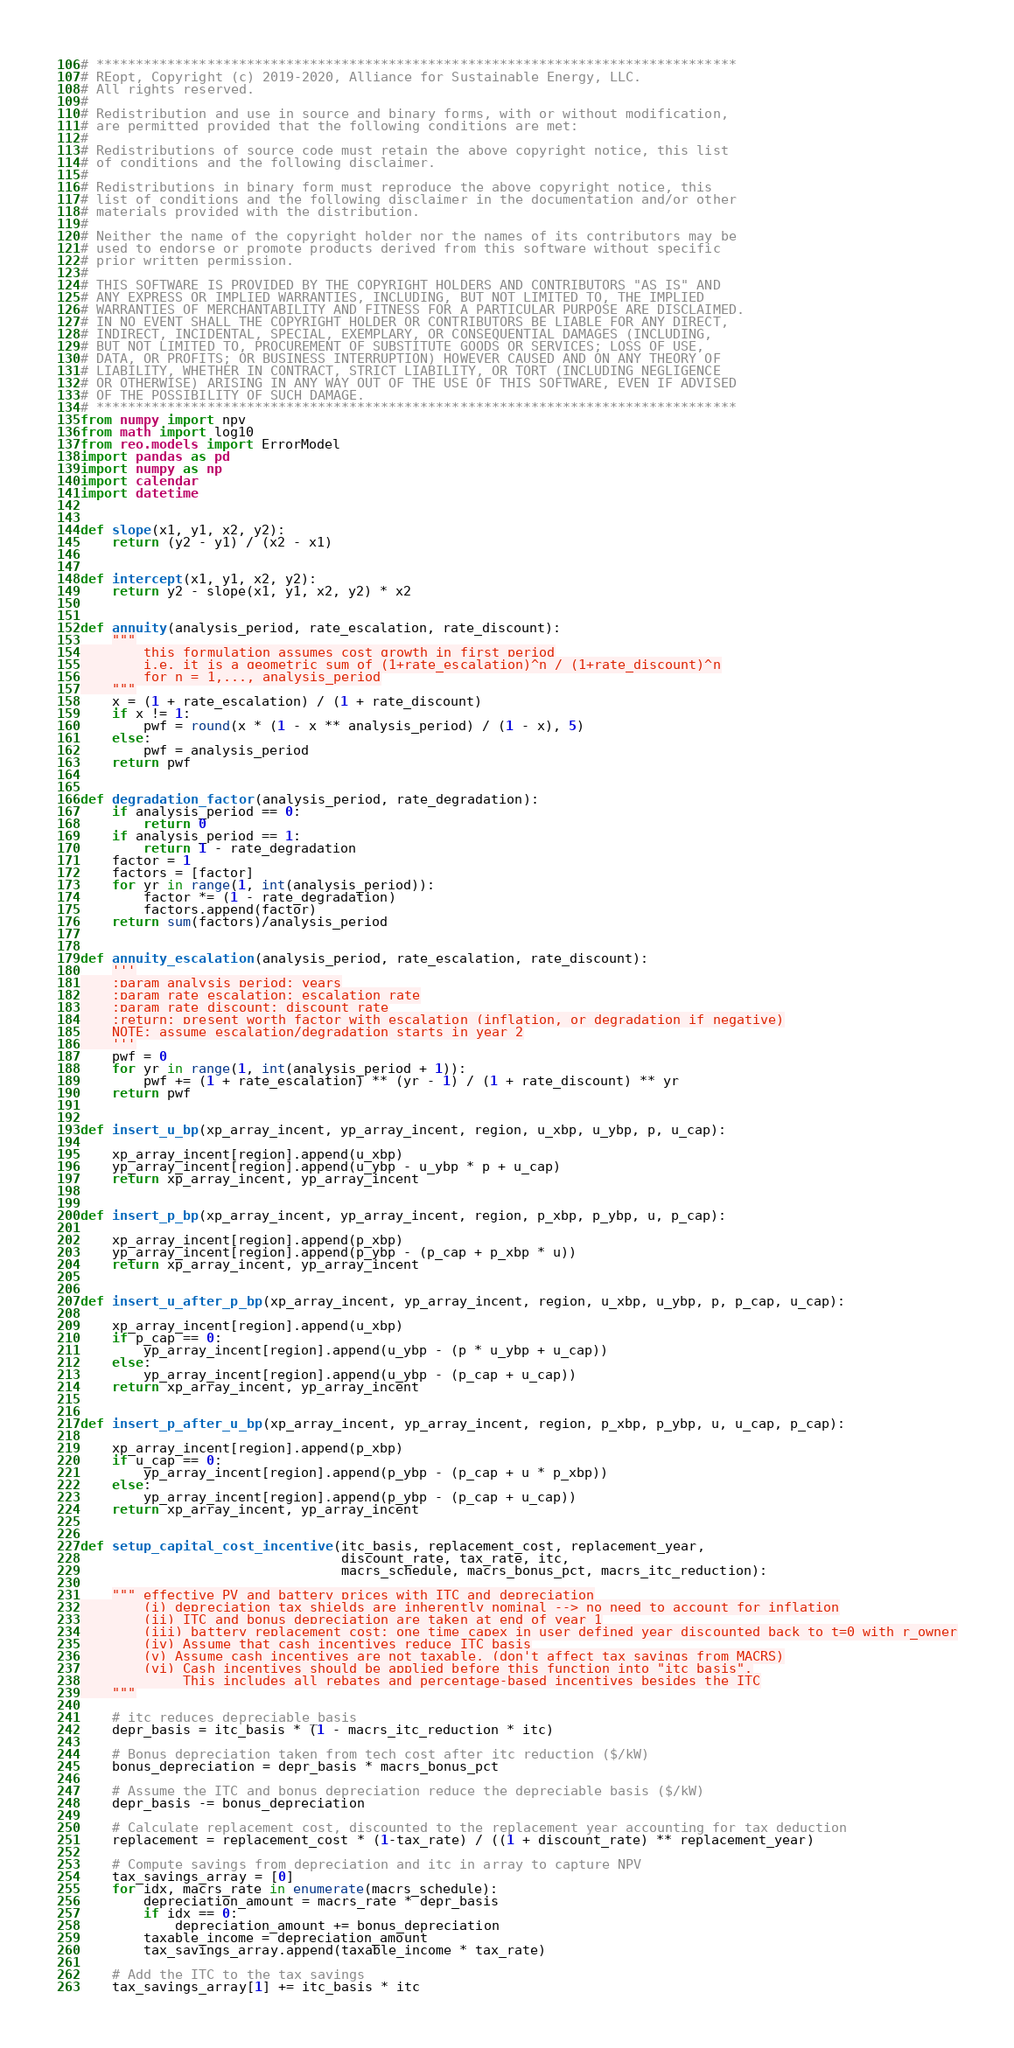<code> <loc_0><loc_0><loc_500><loc_500><_Python_># *********************************************************************************
# REopt, Copyright (c) 2019-2020, Alliance for Sustainable Energy, LLC.
# All rights reserved.
#
# Redistribution and use in source and binary forms, with or without modification,
# are permitted provided that the following conditions are met:
#
# Redistributions of source code must retain the above copyright notice, this list
# of conditions and the following disclaimer.
#
# Redistributions in binary form must reproduce the above copyright notice, this
# list of conditions and the following disclaimer in the documentation and/or other
# materials provided with the distribution.
#
# Neither the name of the copyright holder nor the names of its contributors may be
# used to endorse or promote products derived from this software without specific
# prior written permission.
#
# THIS SOFTWARE IS PROVIDED BY THE COPYRIGHT HOLDERS AND CONTRIBUTORS "AS IS" AND
# ANY EXPRESS OR IMPLIED WARRANTIES, INCLUDING, BUT NOT LIMITED TO, THE IMPLIED
# WARRANTIES OF MERCHANTABILITY AND FITNESS FOR A PARTICULAR PURPOSE ARE DISCLAIMED.
# IN NO EVENT SHALL THE COPYRIGHT HOLDER OR CONTRIBUTORS BE LIABLE FOR ANY DIRECT,
# INDIRECT, INCIDENTAL, SPECIAL, EXEMPLARY, OR CONSEQUENTIAL DAMAGES (INCLUDING,
# BUT NOT LIMITED TO, PROCUREMENT OF SUBSTITUTE GOODS OR SERVICES; LOSS OF USE,
# DATA, OR PROFITS; OR BUSINESS INTERRUPTION) HOWEVER CAUSED AND ON ANY THEORY OF
# LIABILITY, WHETHER IN CONTRACT, STRICT LIABILITY, OR TORT (INCLUDING NEGLIGENCE
# OR OTHERWISE) ARISING IN ANY WAY OUT OF THE USE OF THIS SOFTWARE, EVEN IF ADVISED
# OF THE POSSIBILITY OF SUCH DAMAGE.
# *********************************************************************************
from numpy import npv
from math import log10
from reo.models import ErrorModel
import pandas as pd
import numpy as np
import calendar
import datetime


def slope(x1, y1, x2, y2):
    return (y2 - y1) / (x2 - x1)


def intercept(x1, y1, x2, y2):
    return y2 - slope(x1, y1, x2, y2) * x2


def annuity(analysis_period, rate_escalation, rate_discount):
    """
        this formulation assumes cost growth in first period
        i.e. it is a geometric sum of (1+rate_escalation)^n / (1+rate_discount)^n
        for n = 1,..., analysis_period
    """
    x = (1 + rate_escalation) / (1 + rate_discount)
    if x != 1:
        pwf = round(x * (1 - x ** analysis_period) / (1 - x), 5)
    else:
        pwf = analysis_period
    return pwf


def degradation_factor(analysis_period, rate_degradation):
    if analysis_period == 0:
        return 0
    if analysis_period == 1:
        return 1 - rate_degradation
    factor = 1
    factors = [factor]
    for yr in range(1, int(analysis_period)):
        factor *= (1 - rate_degradation)
        factors.append(factor)
    return sum(factors)/analysis_period


def annuity_escalation(analysis_period, rate_escalation, rate_discount):
    '''
    :param analysis_period: years
    :param rate_escalation: escalation rate
    :param rate_discount: discount rate
    :return: present worth factor with escalation (inflation, or degradation if negative)
    NOTE: assume escalation/degradation starts in year 2
    '''
    pwf = 0
    for yr in range(1, int(analysis_period + 1)):
        pwf += (1 + rate_escalation) ** (yr - 1) / (1 + rate_discount) ** yr
    return pwf


def insert_u_bp(xp_array_incent, yp_array_incent, region, u_xbp, u_ybp, p, u_cap):

    xp_array_incent[region].append(u_xbp)
    yp_array_incent[region].append(u_ybp - u_ybp * p + u_cap)
    return xp_array_incent, yp_array_incent


def insert_p_bp(xp_array_incent, yp_array_incent, region, p_xbp, p_ybp, u, p_cap):

    xp_array_incent[region].append(p_xbp)
    yp_array_incent[region].append(p_ybp - (p_cap + p_xbp * u))
    return xp_array_incent, yp_array_incent


def insert_u_after_p_bp(xp_array_incent, yp_array_incent, region, u_xbp, u_ybp, p, p_cap, u_cap):

    xp_array_incent[region].append(u_xbp)
    if p_cap == 0:
        yp_array_incent[region].append(u_ybp - (p * u_ybp + u_cap))
    else:
        yp_array_incent[region].append(u_ybp - (p_cap + u_cap))
    return xp_array_incent, yp_array_incent


def insert_p_after_u_bp(xp_array_incent, yp_array_incent, region, p_xbp, p_ybp, u, u_cap, p_cap):

    xp_array_incent[region].append(p_xbp)
    if u_cap == 0:
        yp_array_incent[region].append(p_ybp - (p_cap + u * p_xbp))
    else:
        yp_array_incent[region].append(p_ybp - (p_cap + u_cap))
    return xp_array_incent, yp_array_incent


def setup_capital_cost_incentive(itc_basis, replacement_cost, replacement_year,
                                 discount_rate, tax_rate, itc,
                                 macrs_schedule, macrs_bonus_pct, macrs_itc_reduction):

    """ effective PV and battery prices with ITC and depreciation
        (i) depreciation tax shields are inherently nominal --> no need to account for inflation
        (ii) ITC and bonus depreciation are taken at end of year 1
        (iii) battery replacement cost: one time capex in user defined year discounted back to t=0 with r_owner
        (iv) Assume that cash incentives reduce ITC basis
        (v) Assume cash incentives are not taxable, (don't affect tax savings from MACRS)
        (vi) Cash incentives should be applied before this function into "itc_basis".
             This includes all rebates and percentage-based incentives besides the ITC
    """

    # itc reduces depreciable_basis
    depr_basis = itc_basis * (1 - macrs_itc_reduction * itc)

    # Bonus depreciation taken from tech cost after itc reduction ($/kW)
    bonus_depreciation = depr_basis * macrs_bonus_pct

    # Assume the ITC and bonus depreciation reduce the depreciable basis ($/kW)
    depr_basis -= bonus_depreciation

    # Calculate replacement cost, discounted to the replacement year accounting for tax deduction
    replacement = replacement_cost * (1-tax_rate) / ((1 + discount_rate) ** replacement_year)

    # Compute savings from depreciation and itc in array to capture NPV
    tax_savings_array = [0]
    for idx, macrs_rate in enumerate(macrs_schedule):
        depreciation_amount = macrs_rate * depr_basis
        if idx == 0:
            depreciation_amount += bonus_depreciation
        taxable_income = depreciation_amount
        tax_savings_array.append(taxable_income * tax_rate)

    # Add the ITC to the tax savings
    tax_savings_array[1] += itc_basis * itc
</code> 